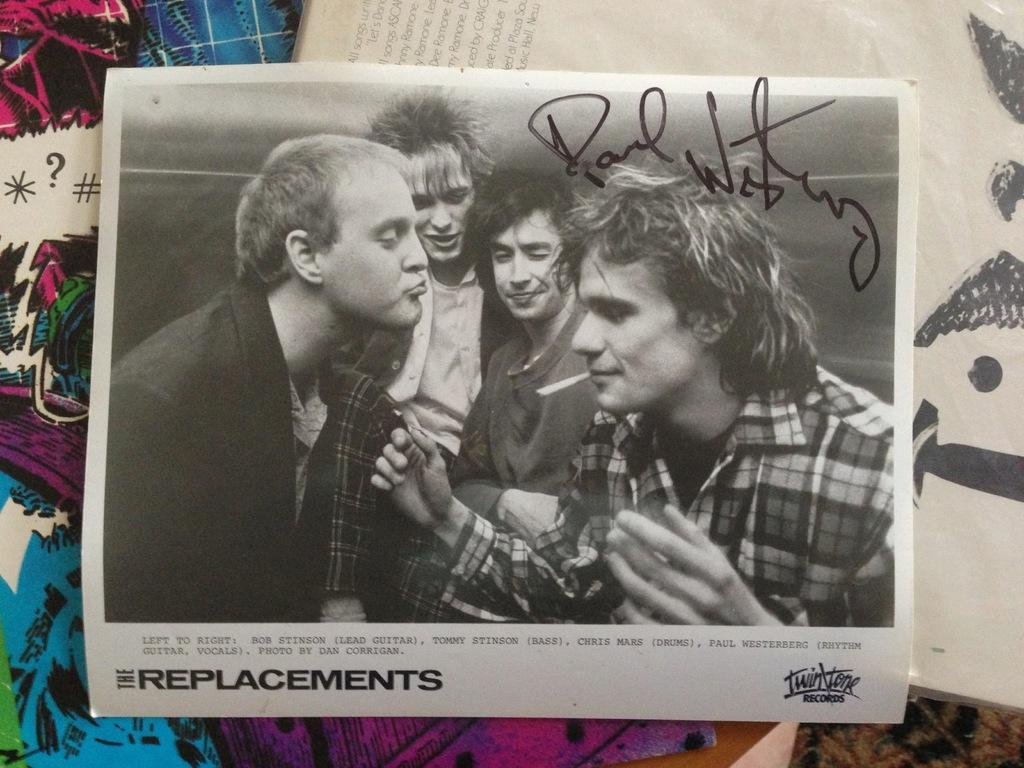What is the main subject of the image? There is a photograph in the image. What can be seen in the photograph? People are standing in the photograph. What are the people in the photograph wearing? The people in the photograph are wearing shirts. What activity are the people in the photograph engaged in? The people in the photograph are smoking. Where is the photograph located in the image? The photograph is placed on a wall. What type of mint is growing near the people in the photograph? There is no mint present in the image, as it only features a photograph of people standing and smoking. 